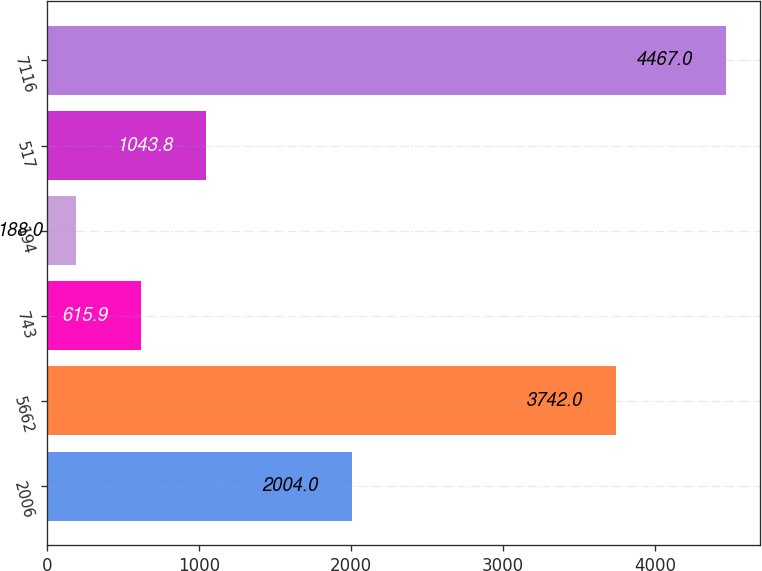Convert chart to OTSL. <chart><loc_0><loc_0><loc_500><loc_500><bar_chart><fcel>2006<fcel>5662<fcel>743<fcel>194<fcel>517<fcel>7116<nl><fcel>2004<fcel>3742<fcel>615.9<fcel>188<fcel>1043.8<fcel>4467<nl></chart> 